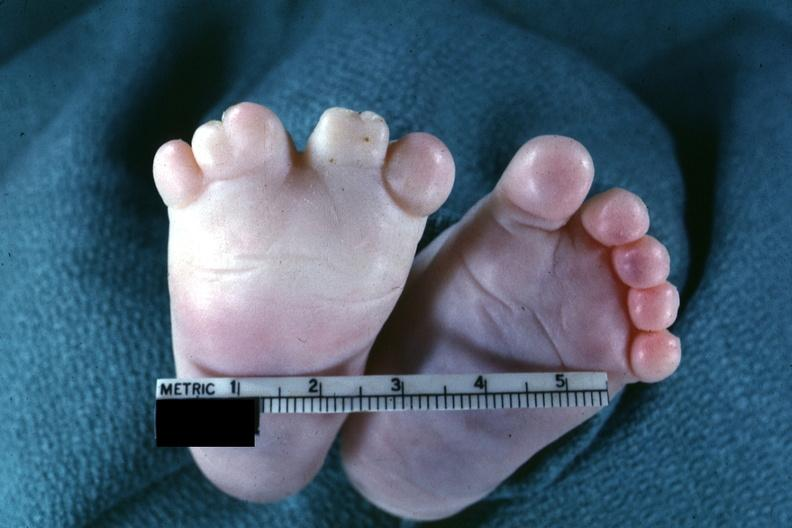s hyalin mass in pituitary which is amyloid there are several slides from this case in this file 23 yowf amyloid limited to brain present?
Answer the question using a single word or phrase. No 